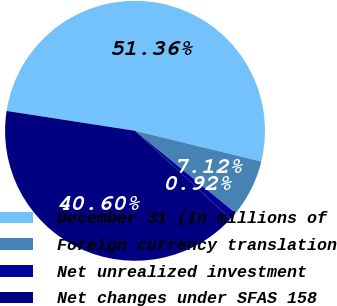<chart> <loc_0><loc_0><loc_500><loc_500><pie_chart><fcel>December 31 (In millions of<fcel>Foreign currency translation<fcel>Net unrealized investment<fcel>Net changes under SFAS 158<nl><fcel>51.36%<fcel>7.12%<fcel>0.92%<fcel>40.6%<nl></chart> 